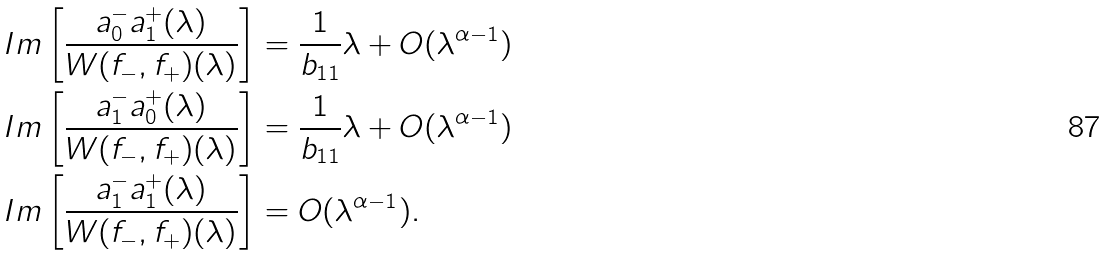<formula> <loc_0><loc_0><loc_500><loc_500>I m \left [ \frac { a _ { 0 } ^ { - } a _ { 1 } ^ { + } ( \lambda ) } { W ( f _ { - } , f _ { + } ) ( \lambda ) } \right ] & = \frac { 1 } { b _ { 1 1 } } \lambda + O ( \lambda ^ { \alpha - 1 } ) \\ I m \left [ \frac { a _ { 1 } ^ { - } a _ { 0 } ^ { + } ( \lambda ) } { W ( f _ { - } , f _ { + } ) ( \lambda ) } \right ] & = \frac { 1 } { b _ { 1 1 } } \lambda + O ( \lambda ^ { \alpha - 1 } ) \\ I m \left [ \frac { a _ { 1 } ^ { - } a _ { 1 } ^ { + } ( \lambda ) } { W ( f _ { - } , f _ { + } ) ( \lambda ) } \right ] & = O ( \lambda ^ { \alpha - 1 } ) .</formula> 